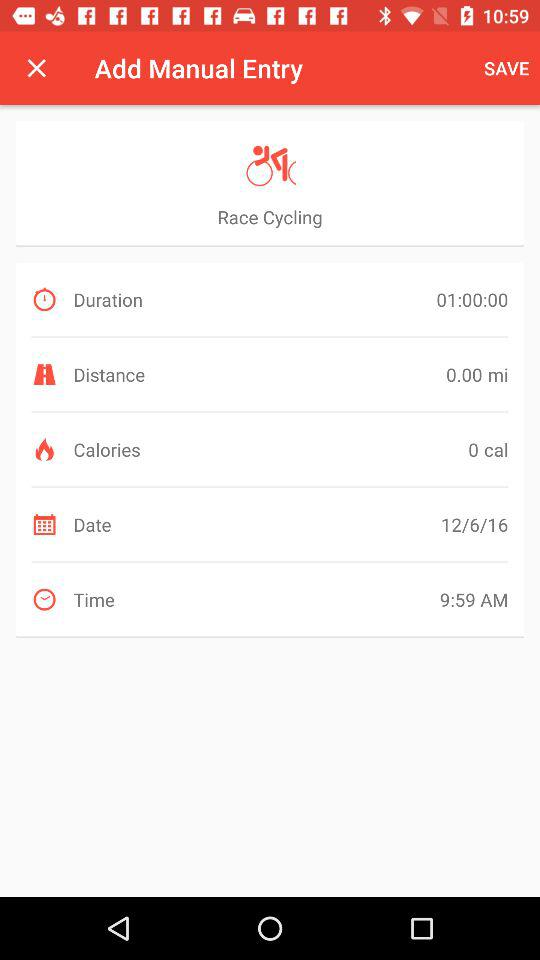How many calories did I burn on this activity?
Answer the question using a single word or phrase. 0 cal 